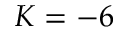<formula> <loc_0><loc_0><loc_500><loc_500>K = - 6</formula> 